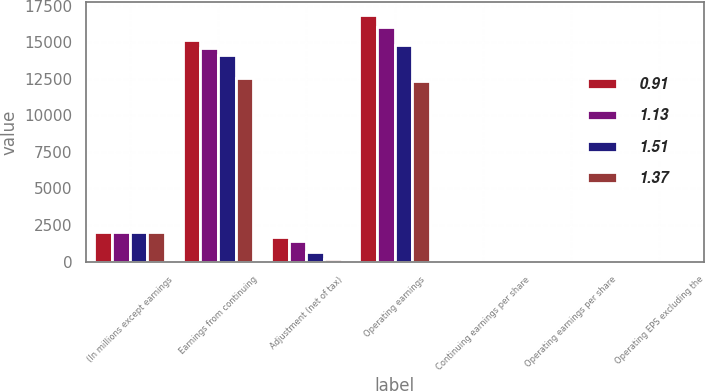Convert chart. <chart><loc_0><loc_0><loc_500><loc_500><stacked_bar_chart><ecel><fcel>(In millions except earnings<fcel>Earnings from continuing<fcel>Adjustment (net of tax)<fcel>Operating earnings<fcel>Continuing earnings per share<fcel>Operating earnings per share<fcel>Operating EPS excluding the<nl><fcel>0.91<fcel>2013<fcel>15177<fcel>1705<fcel>16882<fcel>1.47<fcel>1.64<fcel>1.64<nl><fcel>1.13<fcel>2012<fcel>14624<fcel>1386<fcel>16010<fcel>1.38<fcel>1.51<fcel>1.51<nl><fcel>1.51<fcel>2011<fcel>14122<fcel>688<fcel>14810<fcel>1.23<fcel>1.3<fcel>1.37<nl><fcel>1.37<fcel>2010<fcel>12577<fcel>204<fcel>12373<fcel>1.15<fcel>1.13<fcel>1.13<nl></chart> 